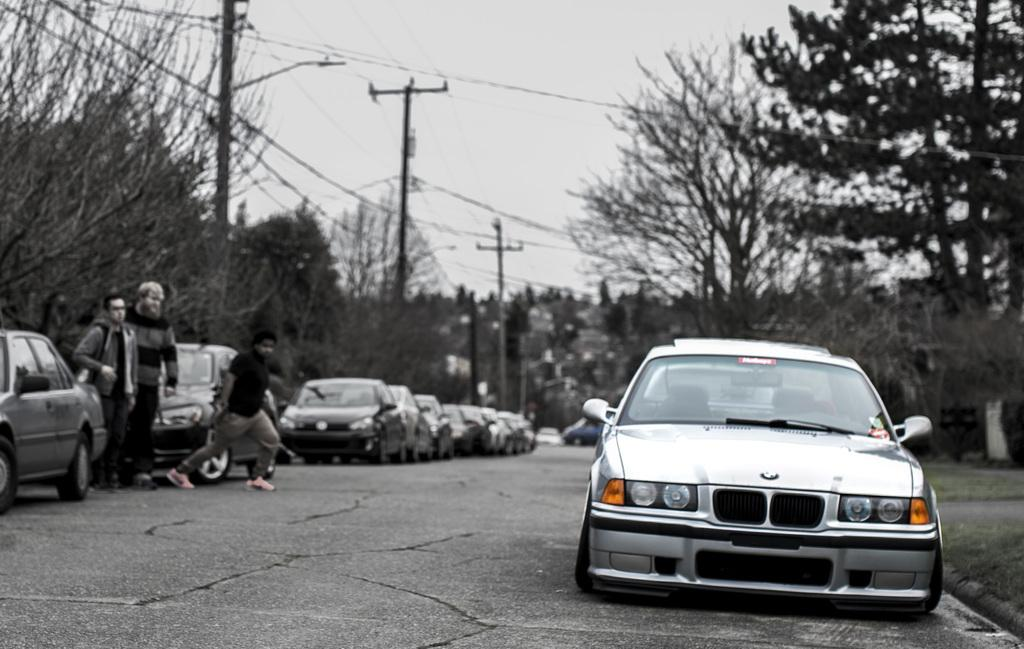What can be seen on the road in the image? There are cars on the road in the image. How many people are standing near the cars? There are three persons standing near the cars. What is visible in the background of the image? There are trees, poles with wires, and the sky visible in the background of the image. Can you see any visible veins on the trees in the image? There is no mention of visible veins on the trees in the image, and it is not possible to determine the presence of veins from the image alone. Is the water in the image comfortable for swimming? There is no water present in the image, so it is not possible to determine if it would be comfortable for swimming. 